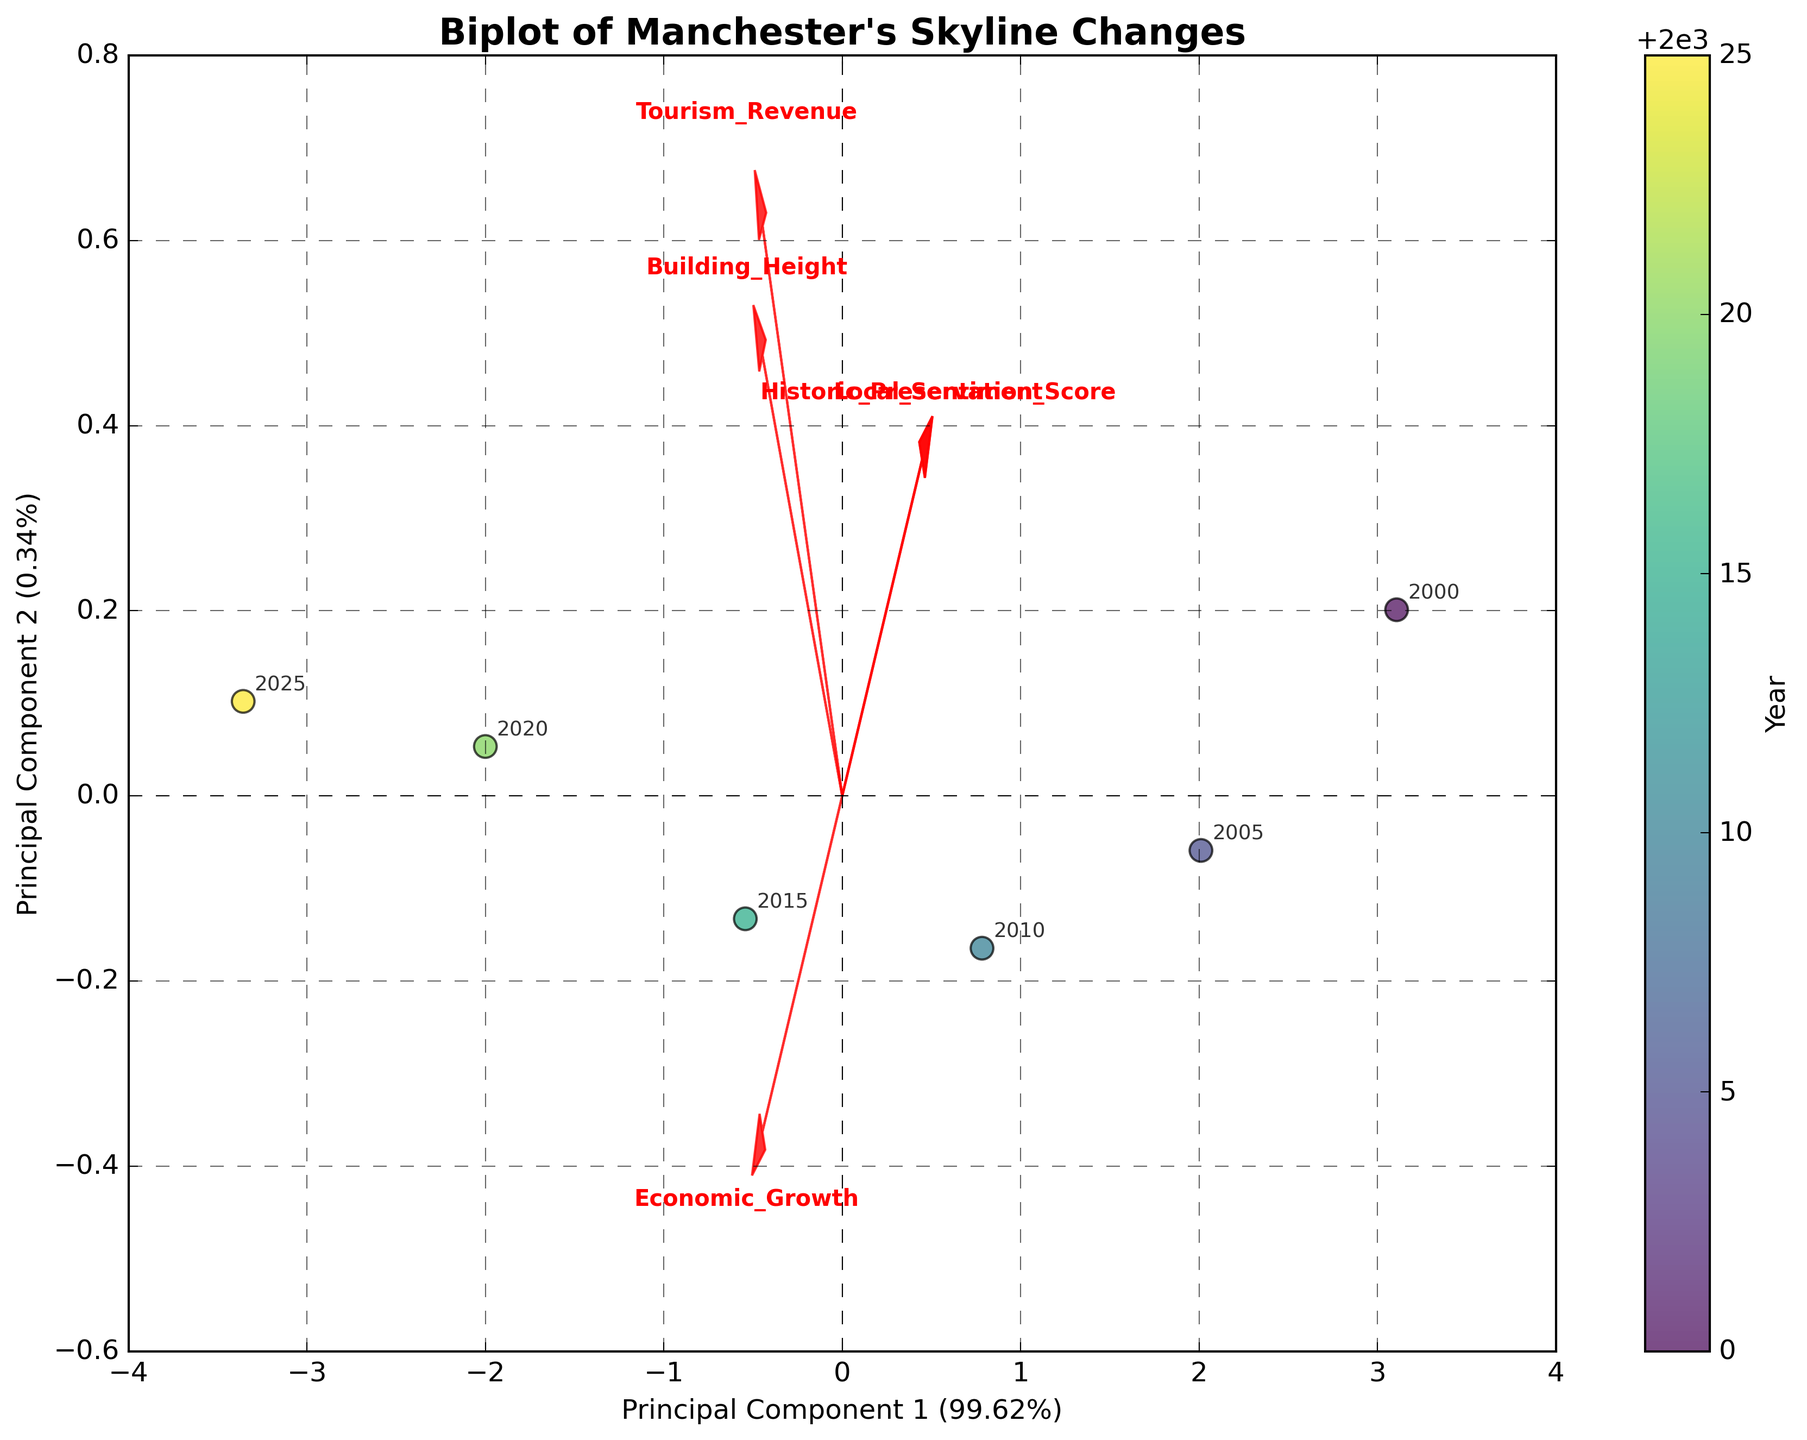What is the title of the figure? The title is the text at the top of the figure, indicating the overall topic or focus of the data presented.
Answer: "Biplot of Manchester's Skyline Changes" What are the labels for the two axes? The labels for the axes provide the names of the components represented. They are written next to each axis.
Answer: "Principal Component 1" and "Principal Component 2" How many feature vectors (red arrows) are present in the plot? By counting the number of red arrows in the biplot, we determine the number of feature vectors represented.
Answer: 5 Which principal component explains a higher percentage of the variance? The percentages of explained variance for each component are given in the axis labels. The component with the higher percentage explains more variance.
Answer: Principal Component 1 Which year is furthest from the origin in the plot? The data points are marked with the year they represent. The point furthest from the center (origin) of the plot indicates the year requested.
Answer: 2025 Which feature vector points most closely in the same direction as "Economic_Growth"? By observing the arrows, we identify which vector is pointing in nearly the same direction as the "Economic_Growth" vector, indicating a similar orientation.
Answer: "Building_Height" Between "Tourism_Revenue" and "Local_Sentiment," which feature vector is more aligned with "Principal Component 2"? By comparing the angles of the arrows with the vertical axis (Principal Component 2), we can see which one is more closely aligned.
Answer: "Local_Sentiment" How does "Historic_Preservation_Score" change relative to "Building_Height" from 2000 to 2025? Using the figures, we see that as "Building_Height" increases over the years, we look at the orientation of "Historic_Preservation_Score" to determine if it increases, decreases, or remains constant. The arrow direction for each feature and the alignment with the principal components help us understand this.
Answer: Decreases Is "Tourism_Revenue" more correlated with "Economic_Growth" or "Local_Sentiment" based on the biplot? We analyze the angles between the vectors representing "Tourism_Revenue" and the other two features. Smaller angles indicate higher correlations.
Answer: "Economic_Growth" Which year has the highest tourism revenue according to the plot? By checking the colors of the data points and their annotation, we can identify which year corresponds to the highest point on the "Tourism_Revenue" vector.
Answer: 2025 